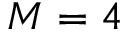<formula> <loc_0><loc_0><loc_500><loc_500>M = 4</formula> 